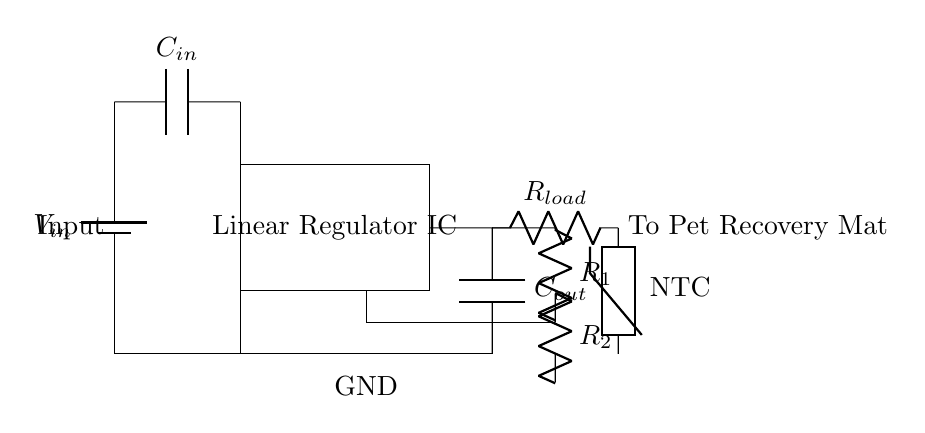what component regulates the voltage in this circuit? The component that regulates the voltage in this circuit is the Linear Regulator IC. It controls the output voltage provided to the load (pet recovery mat) based on the input voltage and the feedback from the output.
Answer: Linear Regulator IC what is the purpose of the input capacitor? The purpose of the input capacitor, labeled as C_in, is to stabilize the input voltage by reducing voltage fluctuations or noise. It provides a reservoir of charge that helps maintain a steady voltage for the linear regulator to work effectively.
Answer: Stabilize input voltage what type of thermistor is used in this circuit? The circuit uses a Negative Temperature Coefficient (NTC) thermistor, which means its resistance decreases as the temperature increases. This characteristic is useful for temperature feedback in applications like a pet recovery mat.
Answer: NTC how many resistors are present in the feedback loop? There are two resistors in the feedback loop, named R1 and R2. They form a voltage divider that helps the linear regulator maintain the desired output voltage by providing feedback relative to the output voltage.
Answer: Two what is the load connected to the output of the regulator? The load connected to the output of the regulator is the pet recovery mat, which utilizes the regulated voltage to provide controlled heating for recovery purposes.
Answer: Pet Recovery Mat what kind of capacitor is connected at the output? The capacitor connected at the output is identified as C_out. Its role is to filter the output voltage, ensuring that any fluctuations are minimized for smooth power supply to the load (pet recovery mat).
Answer: Output capacitor 